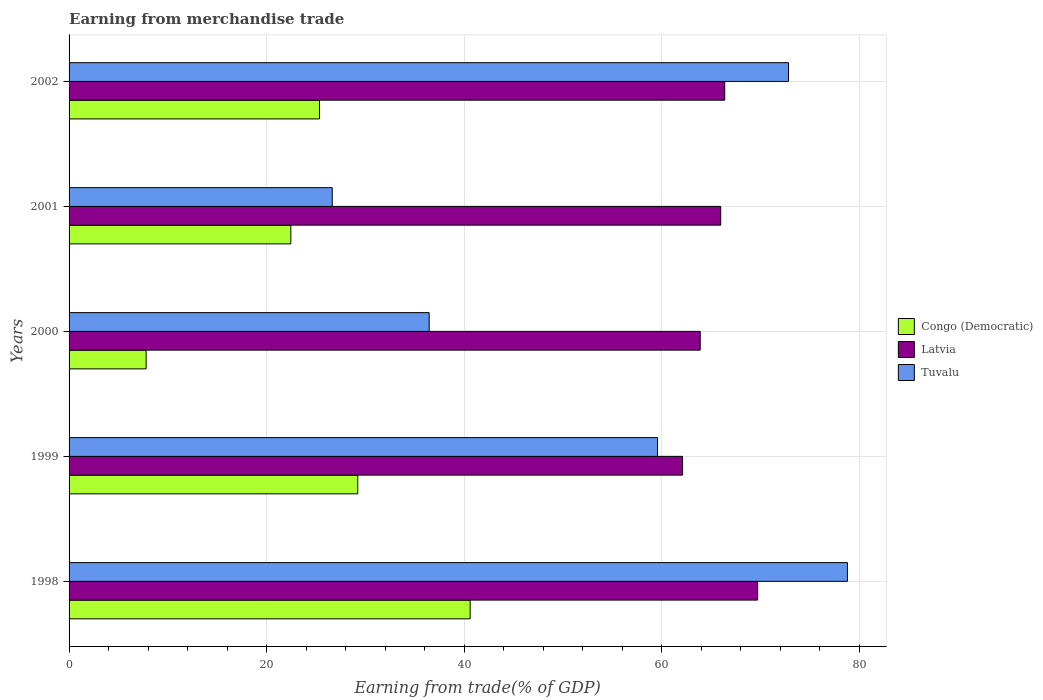What is the label of the 2nd group of bars from the top?
Provide a succinct answer. 2001. What is the earnings from trade in Tuvalu in 1999?
Provide a short and direct response. 59.58. Across all years, what is the maximum earnings from trade in Congo (Democratic)?
Make the answer very short. 40.61. Across all years, what is the minimum earnings from trade in Tuvalu?
Ensure brevity in your answer.  26.64. What is the total earnings from trade in Tuvalu in the graph?
Offer a terse response. 274.32. What is the difference between the earnings from trade in Latvia in 2001 and that in 2002?
Offer a terse response. -0.41. What is the difference between the earnings from trade in Tuvalu in 1999 and the earnings from trade in Latvia in 2002?
Offer a terse response. -6.8. What is the average earnings from trade in Latvia per year?
Your answer should be very brief. 65.61. In the year 2002, what is the difference between the earnings from trade in Congo (Democratic) and earnings from trade in Latvia?
Your answer should be compact. -41.03. In how many years, is the earnings from trade in Tuvalu greater than 72 %?
Offer a terse response. 2. What is the ratio of the earnings from trade in Tuvalu in 1998 to that in 2001?
Keep it short and to the point. 2.96. What is the difference between the highest and the second highest earnings from trade in Congo (Democratic)?
Your answer should be compact. 11.38. What is the difference between the highest and the lowest earnings from trade in Latvia?
Provide a succinct answer. 7.6. Is the sum of the earnings from trade in Latvia in 2001 and 2002 greater than the maximum earnings from trade in Congo (Democratic) across all years?
Provide a short and direct response. Yes. What does the 2nd bar from the top in 2002 represents?
Make the answer very short. Latvia. What does the 3rd bar from the bottom in 1999 represents?
Ensure brevity in your answer.  Tuvalu. Is it the case that in every year, the sum of the earnings from trade in Congo (Democratic) and earnings from trade in Latvia is greater than the earnings from trade in Tuvalu?
Ensure brevity in your answer.  Yes. How many years are there in the graph?
Give a very brief answer. 5. What is the difference between two consecutive major ticks on the X-axis?
Your answer should be compact. 20. Are the values on the major ticks of X-axis written in scientific E-notation?
Make the answer very short. No. Does the graph contain any zero values?
Your answer should be very brief. No. Does the graph contain grids?
Keep it short and to the point. Yes. Where does the legend appear in the graph?
Offer a terse response. Center right. How many legend labels are there?
Provide a succinct answer. 3. What is the title of the graph?
Provide a short and direct response. Earning from merchandise trade. Does "Lower middle income" appear as one of the legend labels in the graph?
Ensure brevity in your answer.  No. What is the label or title of the X-axis?
Offer a very short reply. Earning from trade(% of GDP). What is the label or title of the Y-axis?
Provide a succinct answer. Years. What is the Earning from trade(% of GDP) of Congo (Democratic) in 1998?
Give a very brief answer. 40.61. What is the Earning from trade(% of GDP) of Latvia in 1998?
Your response must be concise. 69.71. What is the Earning from trade(% of GDP) in Tuvalu in 1998?
Give a very brief answer. 78.8. What is the Earning from trade(% of GDP) in Congo (Democratic) in 1999?
Your answer should be compact. 29.23. What is the Earning from trade(% of GDP) of Latvia in 1999?
Make the answer very short. 62.11. What is the Earning from trade(% of GDP) in Tuvalu in 1999?
Make the answer very short. 59.58. What is the Earning from trade(% of GDP) in Congo (Democratic) in 2000?
Your answer should be very brief. 7.8. What is the Earning from trade(% of GDP) in Latvia in 2000?
Give a very brief answer. 63.9. What is the Earning from trade(% of GDP) in Tuvalu in 2000?
Offer a terse response. 36.46. What is the Earning from trade(% of GDP) in Congo (Democratic) in 2001?
Give a very brief answer. 22.45. What is the Earning from trade(% of GDP) in Latvia in 2001?
Provide a short and direct response. 65.97. What is the Earning from trade(% of GDP) of Tuvalu in 2001?
Ensure brevity in your answer.  26.64. What is the Earning from trade(% of GDP) of Congo (Democratic) in 2002?
Provide a short and direct response. 25.35. What is the Earning from trade(% of GDP) of Latvia in 2002?
Your answer should be compact. 66.38. What is the Earning from trade(% of GDP) in Tuvalu in 2002?
Provide a succinct answer. 72.84. Across all years, what is the maximum Earning from trade(% of GDP) of Congo (Democratic)?
Offer a terse response. 40.61. Across all years, what is the maximum Earning from trade(% of GDP) in Latvia?
Make the answer very short. 69.71. Across all years, what is the maximum Earning from trade(% of GDP) of Tuvalu?
Your answer should be very brief. 78.8. Across all years, what is the minimum Earning from trade(% of GDP) of Congo (Democratic)?
Provide a succinct answer. 7.8. Across all years, what is the minimum Earning from trade(% of GDP) of Latvia?
Make the answer very short. 62.11. Across all years, what is the minimum Earning from trade(% of GDP) of Tuvalu?
Make the answer very short. 26.64. What is the total Earning from trade(% of GDP) in Congo (Democratic) in the graph?
Keep it short and to the point. 125.44. What is the total Earning from trade(% of GDP) in Latvia in the graph?
Keep it short and to the point. 328.07. What is the total Earning from trade(% of GDP) in Tuvalu in the graph?
Provide a succinct answer. 274.32. What is the difference between the Earning from trade(% of GDP) of Congo (Democratic) in 1998 and that in 1999?
Your answer should be compact. 11.38. What is the difference between the Earning from trade(% of GDP) in Latvia in 1998 and that in 1999?
Offer a very short reply. 7.6. What is the difference between the Earning from trade(% of GDP) in Tuvalu in 1998 and that in 1999?
Provide a short and direct response. 19.23. What is the difference between the Earning from trade(% of GDP) in Congo (Democratic) in 1998 and that in 2000?
Give a very brief answer. 32.8. What is the difference between the Earning from trade(% of GDP) in Latvia in 1998 and that in 2000?
Give a very brief answer. 5.82. What is the difference between the Earning from trade(% of GDP) of Tuvalu in 1998 and that in 2000?
Give a very brief answer. 42.34. What is the difference between the Earning from trade(% of GDP) of Congo (Democratic) in 1998 and that in 2001?
Your response must be concise. 18.16. What is the difference between the Earning from trade(% of GDP) in Latvia in 1998 and that in 2001?
Your response must be concise. 3.74. What is the difference between the Earning from trade(% of GDP) of Tuvalu in 1998 and that in 2001?
Offer a very short reply. 52.16. What is the difference between the Earning from trade(% of GDP) in Congo (Democratic) in 1998 and that in 2002?
Offer a terse response. 15.26. What is the difference between the Earning from trade(% of GDP) of Latvia in 1998 and that in 2002?
Offer a terse response. 3.33. What is the difference between the Earning from trade(% of GDP) of Tuvalu in 1998 and that in 2002?
Provide a short and direct response. 5.96. What is the difference between the Earning from trade(% of GDP) in Congo (Democratic) in 1999 and that in 2000?
Provide a succinct answer. 21.43. What is the difference between the Earning from trade(% of GDP) of Latvia in 1999 and that in 2000?
Your answer should be very brief. -1.79. What is the difference between the Earning from trade(% of GDP) of Tuvalu in 1999 and that in 2000?
Provide a succinct answer. 23.12. What is the difference between the Earning from trade(% of GDP) in Congo (Democratic) in 1999 and that in 2001?
Provide a succinct answer. 6.78. What is the difference between the Earning from trade(% of GDP) in Latvia in 1999 and that in 2001?
Offer a terse response. -3.86. What is the difference between the Earning from trade(% of GDP) in Tuvalu in 1999 and that in 2001?
Your answer should be compact. 32.93. What is the difference between the Earning from trade(% of GDP) of Congo (Democratic) in 1999 and that in 2002?
Provide a short and direct response. 3.88. What is the difference between the Earning from trade(% of GDP) of Latvia in 1999 and that in 2002?
Give a very brief answer. -4.27. What is the difference between the Earning from trade(% of GDP) in Tuvalu in 1999 and that in 2002?
Provide a short and direct response. -13.27. What is the difference between the Earning from trade(% of GDP) in Congo (Democratic) in 2000 and that in 2001?
Provide a short and direct response. -14.65. What is the difference between the Earning from trade(% of GDP) in Latvia in 2000 and that in 2001?
Ensure brevity in your answer.  -2.08. What is the difference between the Earning from trade(% of GDP) in Tuvalu in 2000 and that in 2001?
Provide a short and direct response. 9.81. What is the difference between the Earning from trade(% of GDP) in Congo (Democratic) in 2000 and that in 2002?
Your answer should be compact. -17.55. What is the difference between the Earning from trade(% of GDP) in Latvia in 2000 and that in 2002?
Keep it short and to the point. -2.48. What is the difference between the Earning from trade(% of GDP) in Tuvalu in 2000 and that in 2002?
Keep it short and to the point. -36.38. What is the difference between the Earning from trade(% of GDP) in Congo (Democratic) in 2001 and that in 2002?
Your answer should be very brief. -2.9. What is the difference between the Earning from trade(% of GDP) in Latvia in 2001 and that in 2002?
Offer a terse response. -0.41. What is the difference between the Earning from trade(% of GDP) in Tuvalu in 2001 and that in 2002?
Offer a terse response. -46.2. What is the difference between the Earning from trade(% of GDP) in Congo (Democratic) in 1998 and the Earning from trade(% of GDP) in Latvia in 1999?
Your answer should be very brief. -21.5. What is the difference between the Earning from trade(% of GDP) in Congo (Democratic) in 1998 and the Earning from trade(% of GDP) in Tuvalu in 1999?
Your answer should be very brief. -18.97. What is the difference between the Earning from trade(% of GDP) of Latvia in 1998 and the Earning from trade(% of GDP) of Tuvalu in 1999?
Keep it short and to the point. 10.14. What is the difference between the Earning from trade(% of GDP) of Congo (Democratic) in 1998 and the Earning from trade(% of GDP) of Latvia in 2000?
Your response must be concise. -23.29. What is the difference between the Earning from trade(% of GDP) in Congo (Democratic) in 1998 and the Earning from trade(% of GDP) in Tuvalu in 2000?
Your answer should be very brief. 4.15. What is the difference between the Earning from trade(% of GDP) in Latvia in 1998 and the Earning from trade(% of GDP) in Tuvalu in 2000?
Your response must be concise. 33.25. What is the difference between the Earning from trade(% of GDP) in Congo (Democratic) in 1998 and the Earning from trade(% of GDP) in Latvia in 2001?
Your answer should be compact. -25.37. What is the difference between the Earning from trade(% of GDP) in Congo (Democratic) in 1998 and the Earning from trade(% of GDP) in Tuvalu in 2001?
Offer a very short reply. 13.96. What is the difference between the Earning from trade(% of GDP) in Latvia in 1998 and the Earning from trade(% of GDP) in Tuvalu in 2001?
Give a very brief answer. 43.07. What is the difference between the Earning from trade(% of GDP) of Congo (Democratic) in 1998 and the Earning from trade(% of GDP) of Latvia in 2002?
Give a very brief answer. -25.77. What is the difference between the Earning from trade(% of GDP) in Congo (Democratic) in 1998 and the Earning from trade(% of GDP) in Tuvalu in 2002?
Your response must be concise. -32.23. What is the difference between the Earning from trade(% of GDP) of Latvia in 1998 and the Earning from trade(% of GDP) of Tuvalu in 2002?
Give a very brief answer. -3.13. What is the difference between the Earning from trade(% of GDP) of Congo (Democratic) in 1999 and the Earning from trade(% of GDP) of Latvia in 2000?
Ensure brevity in your answer.  -34.67. What is the difference between the Earning from trade(% of GDP) in Congo (Democratic) in 1999 and the Earning from trade(% of GDP) in Tuvalu in 2000?
Offer a very short reply. -7.23. What is the difference between the Earning from trade(% of GDP) of Latvia in 1999 and the Earning from trade(% of GDP) of Tuvalu in 2000?
Keep it short and to the point. 25.65. What is the difference between the Earning from trade(% of GDP) of Congo (Democratic) in 1999 and the Earning from trade(% of GDP) of Latvia in 2001?
Give a very brief answer. -36.74. What is the difference between the Earning from trade(% of GDP) in Congo (Democratic) in 1999 and the Earning from trade(% of GDP) in Tuvalu in 2001?
Provide a short and direct response. 2.58. What is the difference between the Earning from trade(% of GDP) of Latvia in 1999 and the Earning from trade(% of GDP) of Tuvalu in 2001?
Ensure brevity in your answer.  35.47. What is the difference between the Earning from trade(% of GDP) of Congo (Democratic) in 1999 and the Earning from trade(% of GDP) of Latvia in 2002?
Keep it short and to the point. -37.15. What is the difference between the Earning from trade(% of GDP) of Congo (Democratic) in 1999 and the Earning from trade(% of GDP) of Tuvalu in 2002?
Make the answer very short. -43.61. What is the difference between the Earning from trade(% of GDP) in Latvia in 1999 and the Earning from trade(% of GDP) in Tuvalu in 2002?
Give a very brief answer. -10.73. What is the difference between the Earning from trade(% of GDP) in Congo (Democratic) in 2000 and the Earning from trade(% of GDP) in Latvia in 2001?
Provide a succinct answer. -58.17. What is the difference between the Earning from trade(% of GDP) of Congo (Democratic) in 2000 and the Earning from trade(% of GDP) of Tuvalu in 2001?
Give a very brief answer. -18.84. What is the difference between the Earning from trade(% of GDP) in Latvia in 2000 and the Earning from trade(% of GDP) in Tuvalu in 2001?
Offer a very short reply. 37.25. What is the difference between the Earning from trade(% of GDP) of Congo (Democratic) in 2000 and the Earning from trade(% of GDP) of Latvia in 2002?
Your answer should be compact. -58.58. What is the difference between the Earning from trade(% of GDP) of Congo (Democratic) in 2000 and the Earning from trade(% of GDP) of Tuvalu in 2002?
Offer a terse response. -65.04. What is the difference between the Earning from trade(% of GDP) of Latvia in 2000 and the Earning from trade(% of GDP) of Tuvalu in 2002?
Make the answer very short. -8.95. What is the difference between the Earning from trade(% of GDP) of Congo (Democratic) in 2001 and the Earning from trade(% of GDP) of Latvia in 2002?
Give a very brief answer. -43.93. What is the difference between the Earning from trade(% of GDP) in Congo (Democratic) in 2001 and the Earning from trade(% of GDP) in Tuvalu in 2002?
Provide a short and direct response. -50.39. What is the difference between the Earning from trade(% of GDP) in Latvia in 2001 and the Earning from trade(% of GDP) in Tuvalu in 2002?
Keep it short and to the point. -6.87. What is the average Earning from trade(% of GDP) in Congo (Democratic) per year?
Keep it short and to the point. 25.09. What is the average Earning from trade(% of GDP) of Latvia per year?
Your answer should be compact. 65.61. What is the average Earning from trade(% of GDP) in Tuvalu per year?
Offer a very short reply. 54.86. In the year 1998, what is the difference between the Earning from trade(% of GDP) in Congo (Democratic) and Earning from trade(% of GDP) in Latvia?
Your answer should be very brief. -29.11. In the year 1998, what is the difference between the Earning from trade(% of GDP) of Congo (Democratic) and Earning from trade(% of GDP) of Tuvalu?
Make the answer very short. -38.19. In the year 1998, what is the difference between the Earning from trade(% of GDP) in Latvia and Earning from trade(% of GDP) in Tuvalu?
Keep it short and to the point. -9.09. In the year 1999, what is the difference between the Earning from trade(% of GDP) of Congo (Democratic) and Earning from trade(% of GDP) of Latvia?
Ensure brevity in your answer.  -32.88. In the year 1999, what is the difference between the Earning from trade(% of GDP) of Congo (Democratic) and Earning from trade(% of GDP) of Tuvalu?
Make the answer very short. -30.35. In the year 1999, what is the difference between the Earning from trade(% of GDP) of Latvia and Earning from trade(% of GDP) of Tuvalu?
Keep it short and to the point. 2.53. In the year 2000, what is the difference between the Earning from trade(% of GDP) of Congo (Democratic) and Earning from trade(% of GDP) of Latvia?
Offer a terse response. -56.09. In the year 2000, what is the difference between the Earning from trade(% of GDP) in Congo (Democratic) and Earning from trade(% of GDP) in Tuvalu?
Your answer should be very brief. -28.66. In the year 2000, what is the difference between the Earning from trade(% of GDP) in Latvia and Earning from trade(% of GDP) in Tuvalu?
Make the answer very short. 27.44. In the year 2001, what is the difference between the Earning from trade(% of GDP) in Congo (Democratic) and Earning from trade(% of GDP) in Latvia?
Offer a very short reply. -43.52. In the year 2001, what is the difference between the Earning from trade(% of GDP) in Congo (Democratic) and Earning from trade(% of GDP) in Tuvalu?
Give a very brief answer. -4.19. In the year 2001, what is the difference between the Earning from trade(% of GDP) of Latvia and Earning from trade(% of GDP) of Tuvalu?
Provide a short and direct response. 39.33. In the year 2002, what is the difference between the Earning from trade(% of GDP) of Congo (Democratic) and Earning from trade(% of GDP) of Latvia?
Offer a very short reply. -41.03. In the year 2002, what is the difference between the Earning from trade(% of GDP) of Congo (Democratic) and Earning from trade(% of GDP) of Tuvalu?
Your response must be concise. -47.49. In the year 2002, what is the difference between the Earning from trade(% of GDP) in Latvia and Earning from trade(% of GDP) in Tuvalu?
Give a very brief answer. -6.46. What is the ratio of the Earning from trade(% of GDP) in Congo (Democratic) in 1998 to that in 1999?
Your answer should be very brief. 1.39. What is the ratio of the Earning from trade(% of GDP) in Latvia in 1998 to that in 1999?
Your answer should be very brief. 1.12. What is the ratio of the Earning from trade(% of GDP) of Tuvalu in 1998 to that in 1999?
Give a very brief answer. 1.32. What is the ratio of the Earning from trade(% of GDP) of Congo (Democratic) in 1998 to that in 2000?
Offer a terse response. 5.2. What is the ratio of the Earning from trade(% of GDP) in Latvia in 1998 to that in 2000?
Keep it short and to the point. 1.09. What is the ratio of the Earning from trade(% of GDP) of Tuvalu in 1998 to that in 2000?
Offer a very short reply. 2.16. What is the ratio of the Earning from trade(% of GDP) of Congo (Democratic) in 1998 to that in 2001?
Ensure brevity in your answer.  1.81. What is the ratio of the Earning from trade(% of GDP) of Latvia in 1998 to that in 2001?
Your answer should be compact. 1.06. What is the ratio of the Earning from trade(% of GDP) in Tuvalu in 1998 to that in 2001?
Your response must be concise. 2.96. What is the ratio of the Earning from trade(% of GDP) of Congo (Democratic) in 1998 to that in 2002?
Make the answer very short. 1.6. What is the ratio of the Earning from trade(% of GDP) of Latvia in 1998 to that in 2002?
Provide a short and direct response. 1.05. What is the ratio of the Earning from trade(% of GDP) of Tuvalu in 1998 to that in 2002?
Offer a terse response. 1.08. What is the ratio of the Earning from trade(% of GDP) in Congo (Democratic) in 1999 to that in 2000?
Your response must be concise. 3.75. What is the ratio of the Earning from trade(% of GDP) of Tuvalu in 1999 to that in 2000?
Your response must be concise. 1.63. What is the ratio of the Earning from trade(% of GDP) of Congo (Democratic) in 1999 to that in 2001?
Offer a very short reply. 1.3. What is the ratio of the Earning from trade(% of GDP) in Latvia in 1999 to that in 2001?
Give a very brief answer. 0.94. What is the ratio of the Earning from trade(% of GDP) of Tuvalu in 1999 to that in 2001?
Give a very brief answer. 2.24. What is the ratio of the Earning from trade(% of GDP) of Congo (Democratic) in 1999 to that in 2002?
Provide a succinct answer. 1.15. What is the ratio of the Earning from trade(% of GDP) of Latvia in 1999 to that in 2002?
Provide a short and direct response. 0.94. What is the ratio of the Earning from trade(% of GDP) of Tuvalu in 1999 to that in 2002?
Provide a short and direct response. 0.82. What is the ratio of the Earning from trade(% of GDP) in Congo (Democratic) in 2000 to that in 2001?
Offer a very short reply. 0.35. What is the ratio of the Earning from trade(% of GDP) of Latvia in 2000 to that in 2001?
Provide a succinct answer. 0.97. What is the ratio of the Earning from trade(% of GDP) in Tuvalu in 2000 to that in 2001?
Keep it short and to the point. 1.37. What is the ratio of the Earning from trade(% of GDP) in Congo (Democratic) in 2000 to that in 2002?
Offer a terse response. 0.31. What is the ratio of the Earning from trade(% of GDP) in Latvia in 2000 to that in 2002?
Give a very brief answer. 0.96. What is the ratio of the Earning from trade(% of GDP) in Tuvalu in 2000 to that in 2002?
Your answer should be compact. 0.5. What is the ratio of the Earning from trade(% of GDP) in Congo (Democratic) in 2001 to that in 2002?
Offer a very short reply. 0.89. What is the ratio of the Earning from trade(% of GDP) of Latvia in 2001 to that in 2002?
Ensure brevity in your answer.  0.99. What is the ratio of the Earning from trade(% of GDP) of Tuvalu in 2001 to that in 2002?
Your answer should be compact. 0.37. What is the difference between the highest and the second highest Earning from trade(% of GDP) of Congo (Democratic)?
Offer a terse response. 11.38. What is the difference between the highest and the second highest Earning from trade(% of GDP) in Latvia?
Your answer should be very brief. 3.33. What is the difference between the highest and the second highest Earning from trade(% of GDP) of Tuvalu?
Give a very brief answer. 5.96. What is the difference between the highest and the lowest Earning from trade(% of GDP) of Congo (Democratic)?
Offer a terse response. 32.8. What is the difference between the highest and the lowest Earning from trade(% of GDP) in Latvia?
Provide a succinct answer. 7.6. What is the difference between the highest and the lowest Earning from trade(% of GDP) in Tuvalu?
Keep it short and to the point. 52.16. 